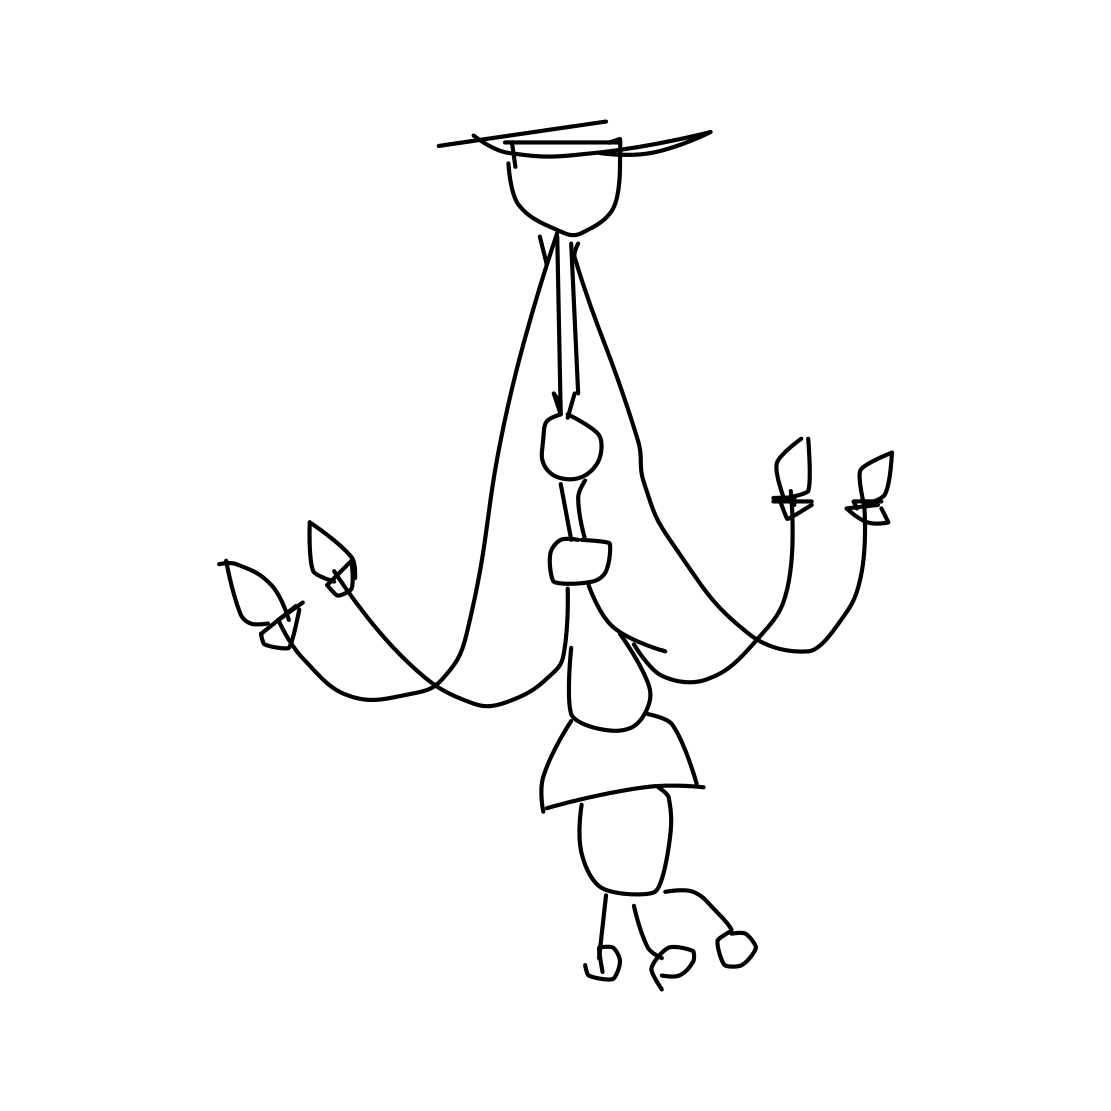What style does this chandelier's design represent? The chandelier's design is indicative of a minimalist or line art style, characterized by the use of clean, uncluttered lines that create a modern and simplistic aesthetic. 